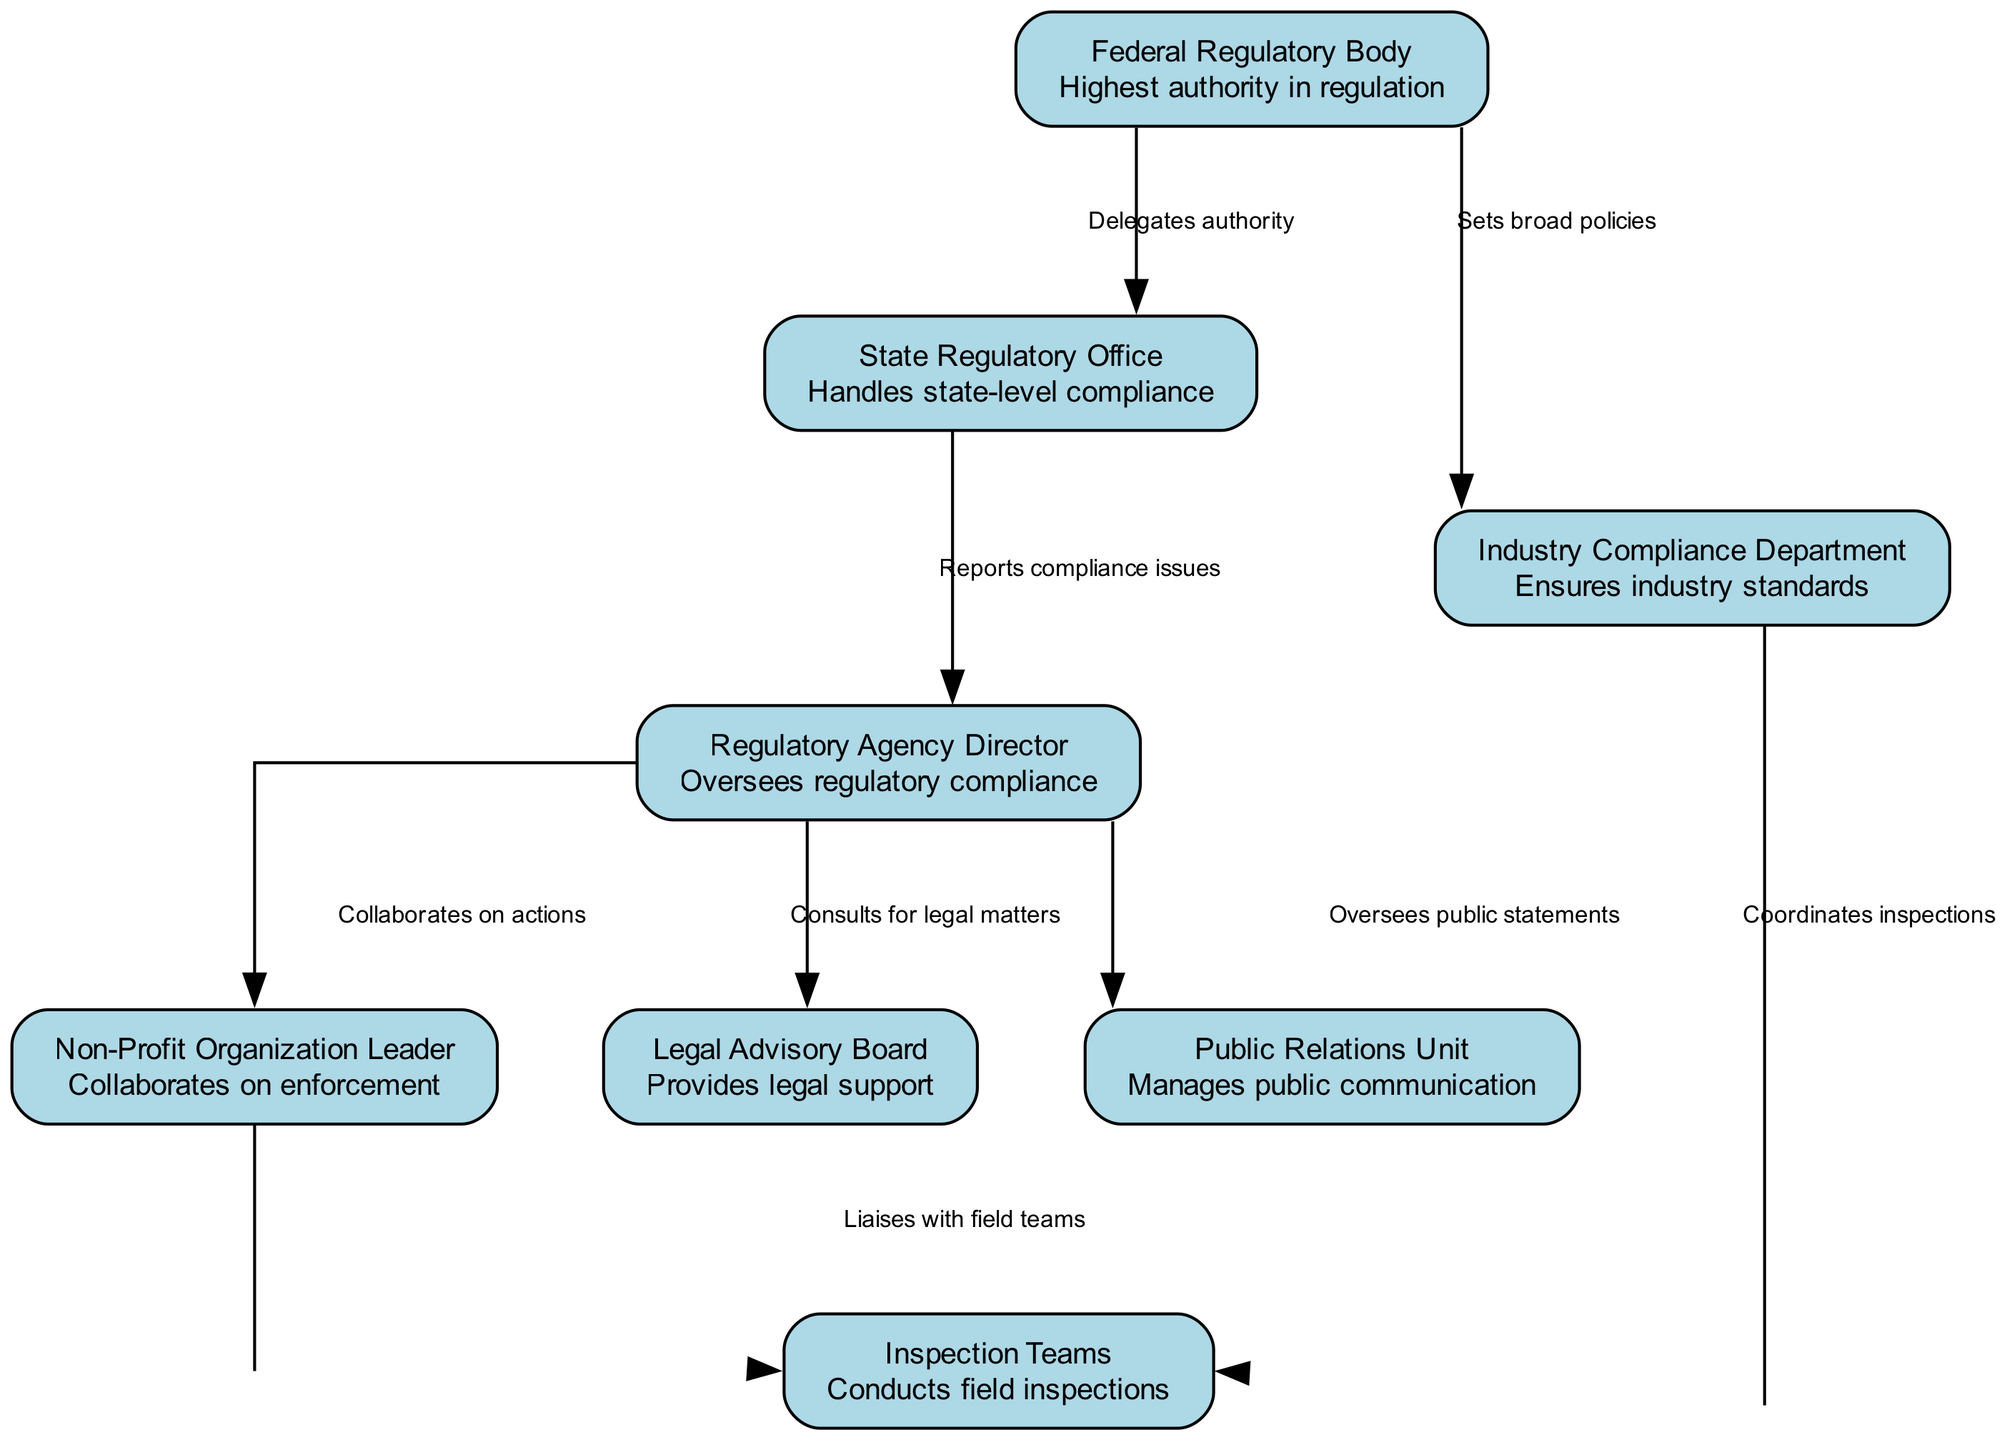What is the highest authority in regulation? The diagram indicates that the "Federal Regulatory Body" is at the top of the hierarchical structure, labeled as the highest authority in regulation.
Answer: Federal Regulatory Body How many nodes are present in the diagram? By counting the listed nodes, there are a total of eight distinct entities depicted within the diagram.
Answer: 8 What role does the State Regulatory Office play in the hierarchy? The diagram describes the "State Regulatory Office" as handling state-level compliance, connected to the Federal Regulatory Body which delegates authority.
Answer: Handles state-level compliance Who does the Inspection Teams liaise with according to the diagram? The "Inspection Teams" are depicted as liaising with the "Non-Profit Organization Leader," indicating a communication flow between these two entities.
Answer: Non-Profit Organization Leader What is the function of the Legal Advisory Board? The diagram specifies the primary function of the "Legal Advisory Board" as providing legal support, indicating its role in assisting with legal compliance and matters related to regulation.
Answer: Provides legal support Which node reports compliance issues? Based on the flow indicated in the diagram, the "State Regulatory Office" is responsible for reporting compliance issues to the "Regulatory Agency Director."
Answer: State Regulatory Office Describe the relationship between the Federal Regulatory Body and the Industry Compliance Department. In the diagram, the relationship is characterized as the Federal Regulatory Body "sets broad policies" which informs the operational guidelines for the Industry Compliance Department to follow.
Answer: Sets broad policies How does the Regulatory Agency Director interact with the Public Relations Unit? The diagram illustrates that the Regulatory Agency Director oversees public statements made by the Public Relations Unit, indicating a management role in communication.
Answer: Oversees public statements 